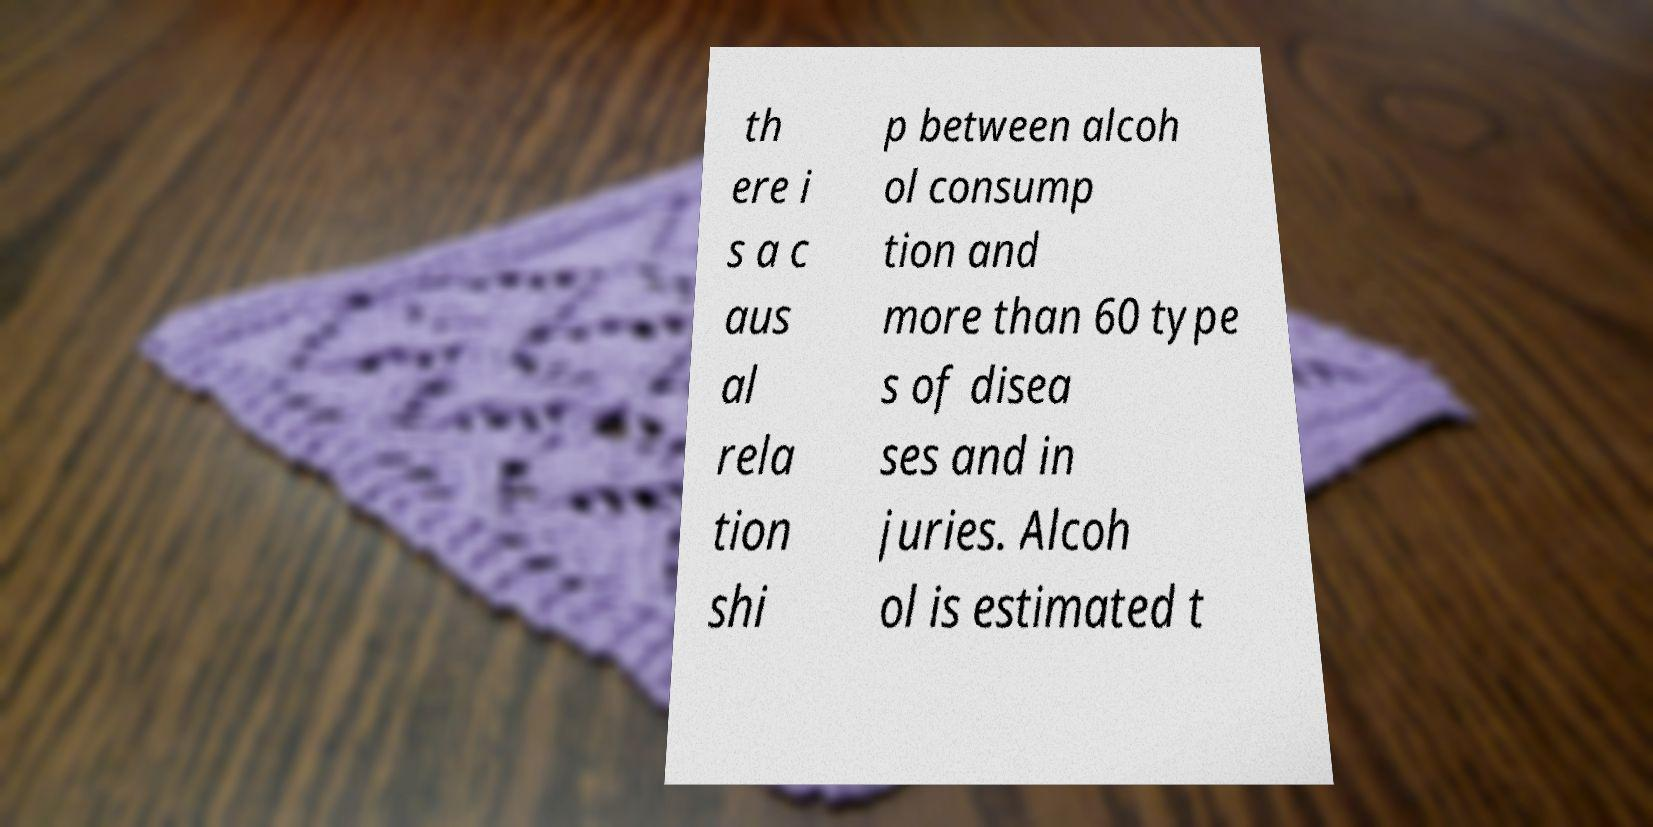Could you extract and type out the text from this image? th ere i s a c aus al rela tion shi p between alcoh ol consump tion and more than 60 type s of disea ses and in juries. Alcoh ol is estimated t 